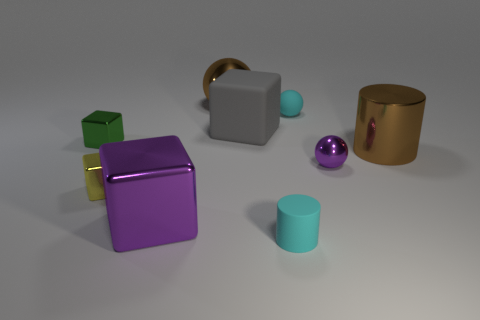There is a matte object that is in front of the large object in front of the large metal object that is right of the large gray matte cube; what color is it?
Keep it short and to the point. Cyan. What number of green things are tiny matte objects or tiny objects?
Provide a short and direct response. 1. How many small yellow things are the same shape as the small green shiny thing?
Provide a succinct answer. 1. There is a green metal thing that is the same size as the cyan sphere; what is its shape?
Ensure brevity in your answer.  Cube. Are there any purple cubes behind the large gray rubber cube?
Your answer should be compact. No. Is there a green thing behind the purple shiny thing that is in front of the purple sphere?
Your answer should be compact. Yes. Are there fewer small rubber spheres in front of the small cylinder than tiny matte things in front of the yellow shiny object?
Provide a succinct answer. Yes. What shape is the large purple thing?
Make the answer very short. Cube. What is the large brown thing behind the big gray thing made of?
Give a very brief answer. Metal. There is a purple metal object to the left of the tiny rubber object behind the large block that is in front of the tiny green cube; what is its size?
Your answer should be compact. Large. 